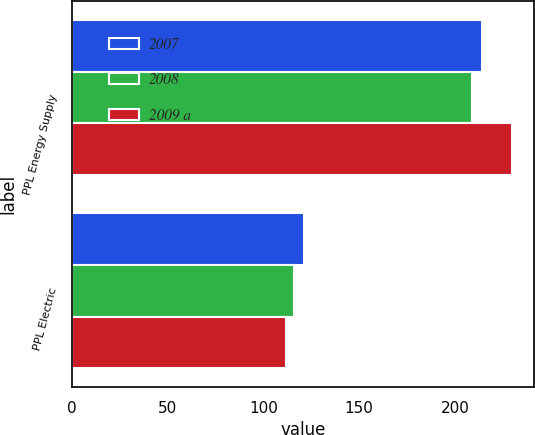Convert chart to OTSL. <chart><loc_0><loc_0><loc_500><loc_500><stacked_bar_chart><ecel><fcel>PPL Energy Supply<fcel>PPL Electric<nl><fcel>2007<fcel>214<fcel>121<nl><fcel>2008<fcel>209<fcel>116<nl><fcel>2009 a<fcel>230<fcel>112<nl></chart> 